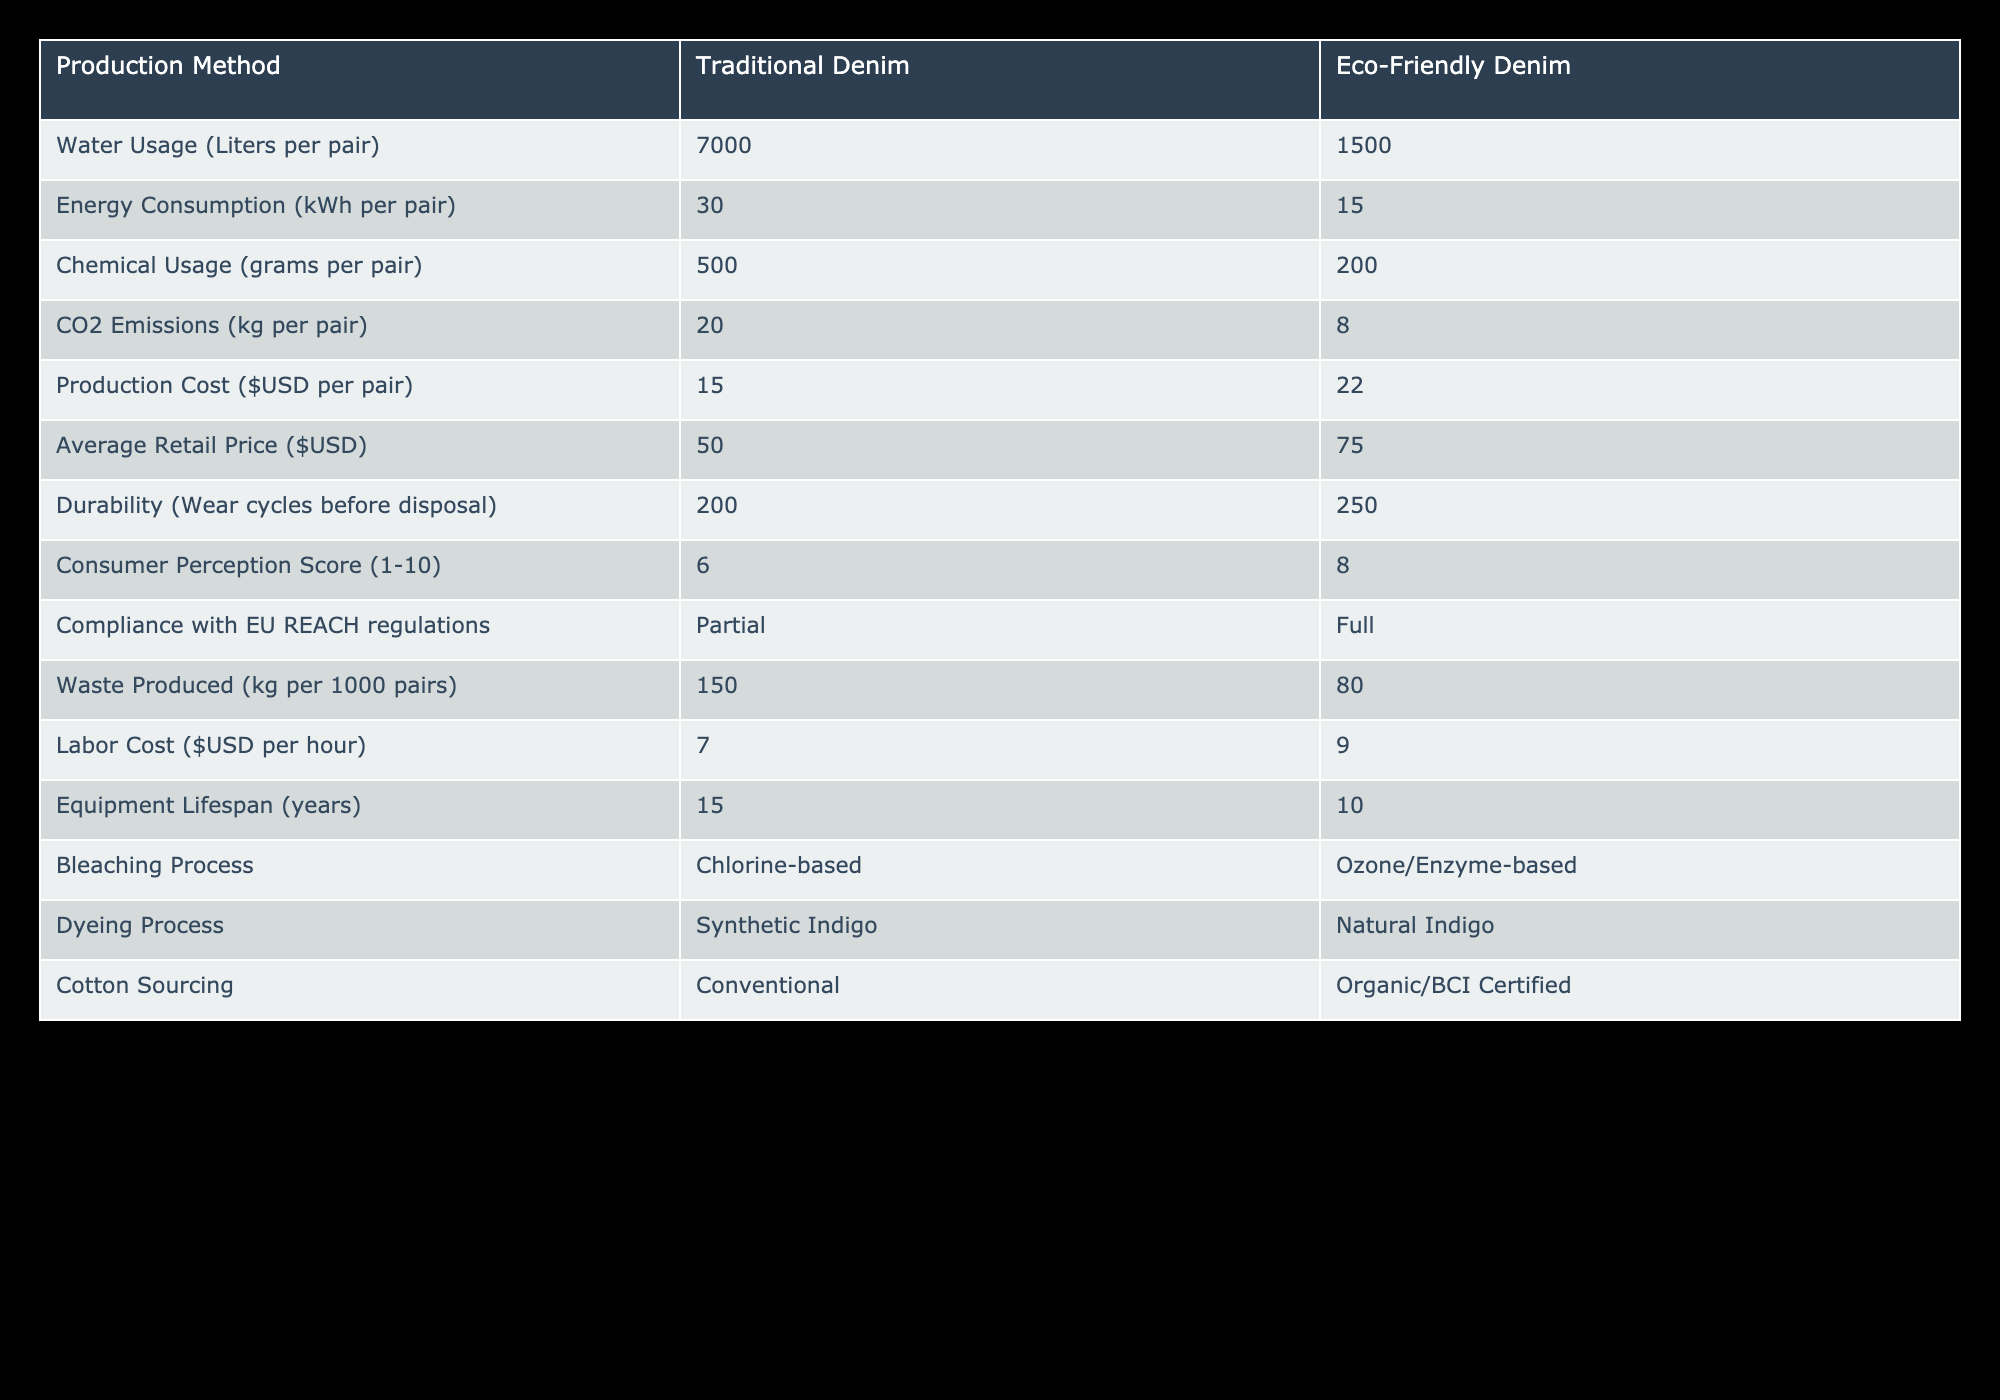What is the water usage for traditional denim production? The table lists the water usage for traditional denim production as 7000 liters per pair. This is found directly in the respective column for traditional denim.
Answer: 7000 liters What is the CO2 emissions per pair for eco-friendly denim compared to traditional denim? The table states that eco-friendly denim production results in CO2 emissions of 8 kg per pair, while traditional denim production has CO2 emissions of 20 kg per pair. The difference shows that eco-friendly denim produces less CO2.
Answer: 8 kg for eco-friendly, 20 kg for traditional Is the average retail price higher for eco-friendly denim? The average retail price for eco-friendly denim is $75, and for traditional denim, it is $50. This confirms that eco-friendly denim has a higher average retail price.
Answer: Yes What is the total reduction in water usage if a manufacturer switches from traditional to eco-friendly denim for 1000 pairs? Traditional denim uses 7000 liters per pair. For 1000 pairs, the total water usage is 7000 liters/pair * 1000 pairs = 7,000,000 liters. Eco-friendly denim uses 1500 liters per pair. For 1000 pairs, it is 1500 liters/pair * 1000 pairs = 1,500,000 liters. The reduction is 7,000,000 - 1,500,000 = 5,500,000 liters.
Answer: 5,500,000 liters How much more does it cost to produce one pair of eco-friendly denim compared to traditional denim? The production cost of eco-friendly denim is $22, while traditional denim costs $15. The difference is $22 - $15 = $7 more for eco-friendly denim.
Answer: $7 more Does eco-friendly denim fully comply with EU REACH regulations? The table indicates that eco-friendly denim has full compliance with EU REACH regulations, while traditional denim only has partial compliance.
Answer: Yes How many wear cycles can one expect from traditional denim before disposal? The durability of traditional denim is listed as 200 wear cycles before disposal, which is directly stated in the table.
Answer: 200 wear cycles What is the average labor cost for traditional denim production compared to eco-friendly denim? The average labor cost for traditional denim is $7 per hour, while for eco-friendly denim it is $9 per hour. This shows that eco-friendly denim has a higher average labor cost.
Answer: $7 for traditional, $9 for eco-friendly What is the difference in chemical usage per pair between traditional and eco-friendly denim? Traditional denim uses 500 grams of chemicals per pair, while eco-friendly denim uses 200 grams. The difference is 500 - 200 = 300 grams.
Answer: 300 grams difference 